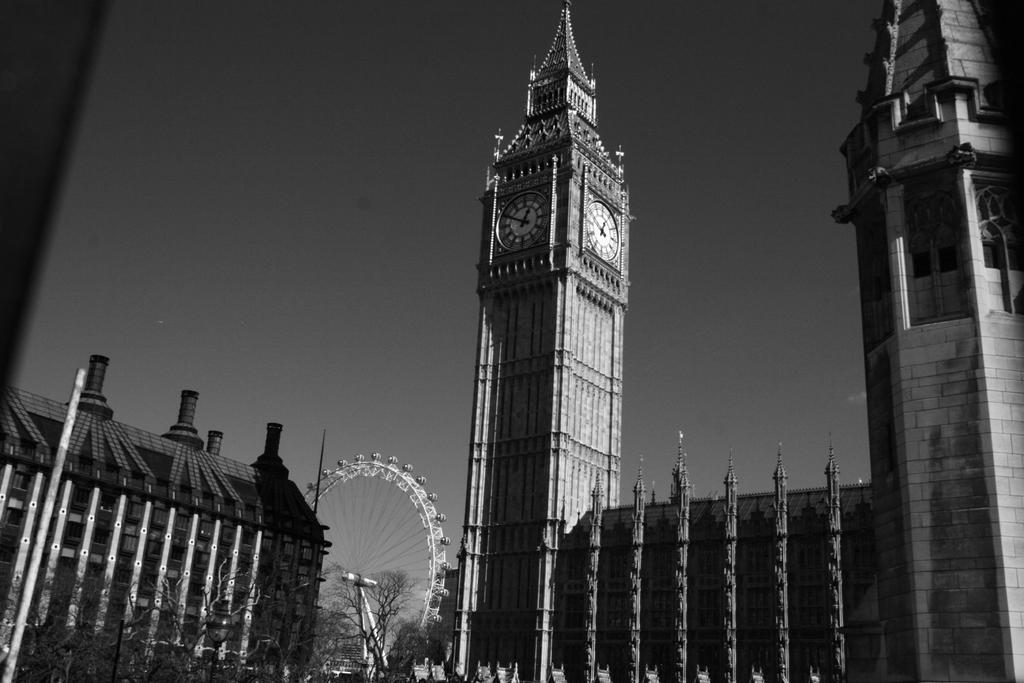What type of structures can be seen in the image? There are buildings and a tower in the image. What feature does the tower have? The tower has a clock. What amusement ride is present in the image? There is a giant wheel in the image. What type of vegetation is visible in the image? Trees are present in the image. What is the condition of the sky in the image? The sky is clear in the image. What type of sleet can be seen falling from the sky in the image? There is no sleet present in the image; the sky is clear. What type of loss is depicted in the image? There is no loss depicted in the image; it features buildings, a tower, a giant wheel, trees, and a clear sky. 